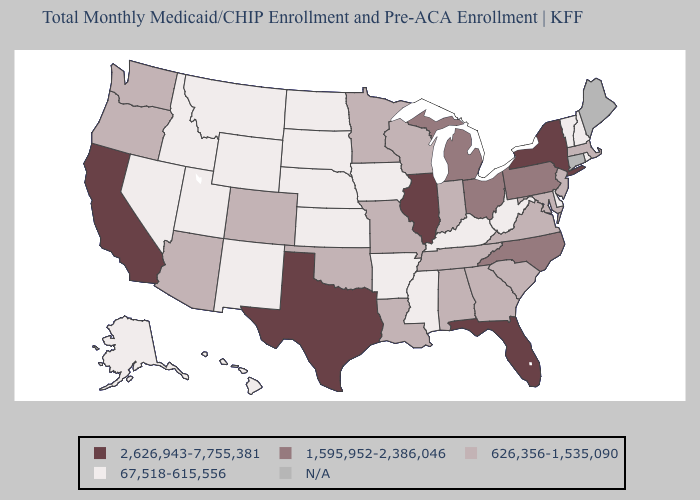Name the states that have a value in the range 1,595,952-2,386,046?
Write a very short answer. Michigan, North Carolina, Ohio, Pennsylvania. Does Washington have the highest value in the West?
Keep it brief. No. Name the states that have a value in the range 2,626,943-7,755,381?
Give a very brief answer. California, Florida, Illinois, New York, Texas. What is the value of Arizona?
Quick response, please. 626,356-1,535,090. Is the legend a continuous bar?
Write a very short answer. No. What is the value of Colorado?
Quick response, please. 626,356-1,535,090. Name the states that have a value in the range N/A?
Concise answer only. Connecticut, Maine. What is the lowest value in the West?
Be succinct. 67,518-615,556. Name the states that have a value in the range 626,356-1,535,090?
Answer briefly. Alabama, Arizona, Colorado, Georgia, Indiana, Louisiana, Maryland, Massachusetts, Minnesota, Missouri, New Jersey, Oklahoma, Oregon, South Carolina, Tennessee, Virginia, Washington, Wisconsin. What is the highest value in the USA?
Answer briefly. 2,626,943-7,755,381. Which states have the highest value in the USA?
Short answer required. California, Florida, Illinois, New York, Texas. What is the value of Connecticut?
Quick response, please. N/A. What is the value of Massachusetts?
Write a very short answer. 626,356-1,535,090. Name the states that have a value in the range N/A?
Concise answer only. Connecticut, Maine. 